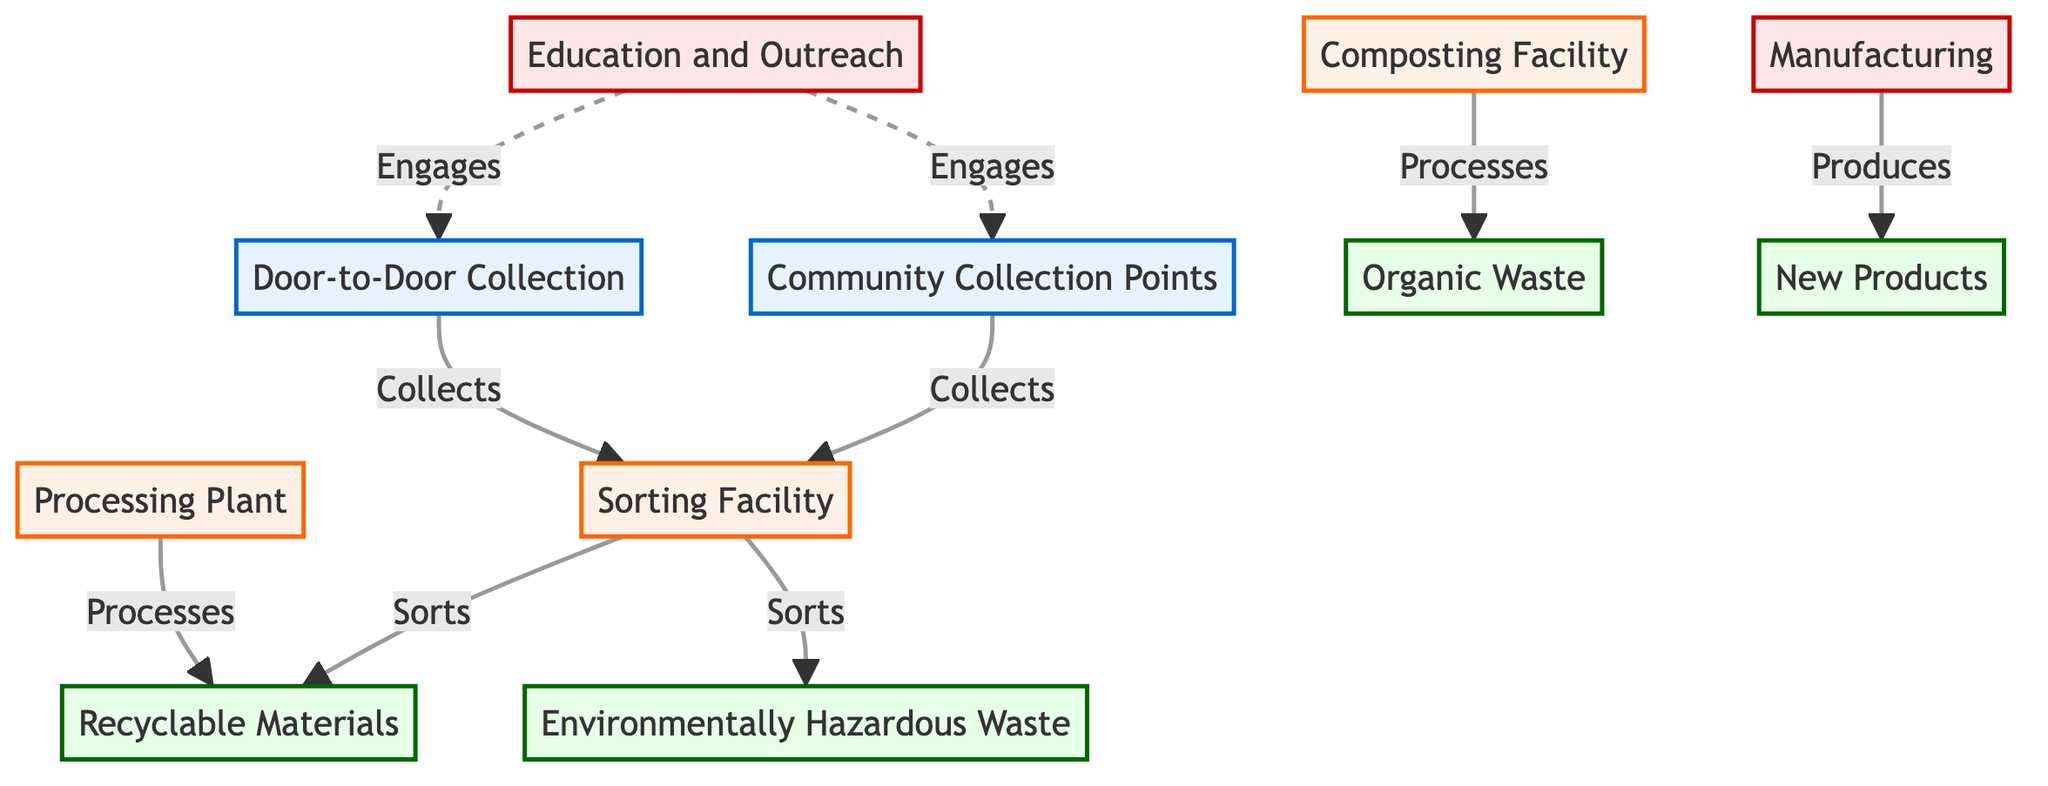What are the two methods of collection listed in the diagram? The diagram shows two collection methods: Community Collection Points and Door-to-Door Collection. These are both labeled as collection points, indicating the starting stage of the recycling process.
Answer: Community Collection Points and Door-to-Door Collection How many types of recyclable materials are identified in the diagram? In the diagram, there are three types of recyclable materials specifically mentioned: Recyclable Materials, Environmentally Hazardous Waste, and Organic Waste. Counting these gives a total of three types.
Answer: 3 What facility processes organic waste? The diagram indicates that the Composting Facility processes organic waste. It is directly linked to the flow of organic material after sorting.
Answer: Composting Facility Which entity engages in education and outreach? According to the diagram, the Education and Outreach process engages with both Community Collection Points and Door-to-Door Collection, making it an integral part of community interaction.
Answer: Education and Outreach What is produced at the Manufacturing stage? The diagram shows that the Manufacturing stage produces New Products, which are derived from the Recyclable Materials processed earlier in the system.
Answer: New Products What type of waste is sorted into the Sorting Facility? In the diagram, the Sorting Facility specifically sorts into Recyclable Materials and Environmentally Hazardous Waste, categorizing these waste types for further processing.
Answer: Recyclable Materials and Environmentally Hazardous Waste How are recyclable materials processed according to the diagram? The diagram shows that Recyclable Materials are processed at the Processing Plant, which is directly linked to the Sorting Facility and is a key step before they reach Manufacturing.
Answer: Processing Plant How does the diagram illustrate community involvement? Community involvement is demonstrated in the diagram through the Education and Outreach process, which engages with community collection methods and promotes awareness and participation in recycling initiatives.
Answer: Education and Outreach 